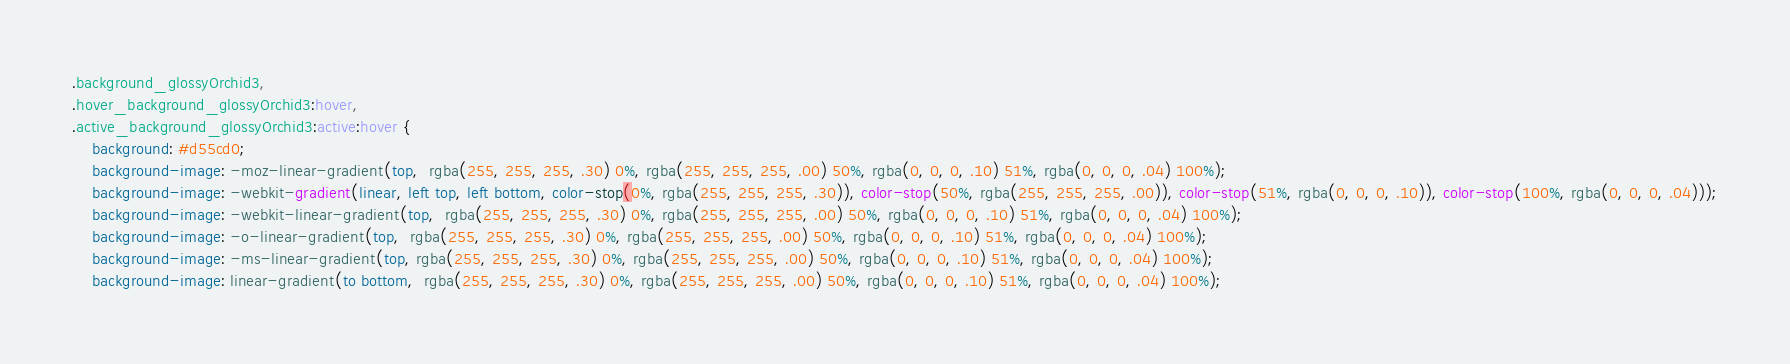<code> <loc_0><loc_0><loc_500><loc_500><_CSS_>.background_glossyOrchid3,
.hover_background_glossyOrchid3:hover,
.active_background_glossyOrchid3:active:hover {
    background: #d55cd0;
    background-image: -moz-linear-gradient(top,  rgba(255, 255, 255, .30) 0%, rgba(255, 255, 255, .00) 50%, rgba(0, 0, 0, .10) 51%, rgba(0, 0, 0, .04) 100%);
    background-image: -webkit-gradient(linear, left top, left bottom, color-stop(0%, rgba(255, 255, 255, .30)), color-stop(50%, rgba(255, 255, 255, .00)), color-stop(51%, rgba(0, 0, 0, .10)), color-stop(100%, rgba(0, 0, 0, .04)));
    background-image: -webkit-linear-gradient(top,  rgba(255, 255, 255, .30) 0%, rgba(255, 255, 255, .00) 50%, rgba(0, 0, 0, .10) 51%, rgba(0, 0, 0, .04) 100%);
    background-image: -o-linear-gradient(top,  rgba(255, 255, 255, .30) 0%, rgba(255, 255, 255, .00) 50%, rgba(0, 0, 0, .10) 51%, rgba(0, 0, 0, .04) 100%);
    background-image: -ms-linear-gradient(top, rgba(255, 255, 255, .30) 0%, rgba(255, 255, 255, .00) 50%, rgba(0, 0, 0, .10) 51%, rgba(0, 0, 0, .04) 100%);
    background-image: linear-gradient(to bottom,  rgba(255, 255, 255, .30) 0%, rgba(255, 255, 255, .00) 50%, rgba(0, 0, 0, .10) 51%, rgba(0, 0, 0, .04) 100%);</code> 